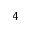<formula> <loc_0><loc_0><loc_500><loc_500>4</formula> 